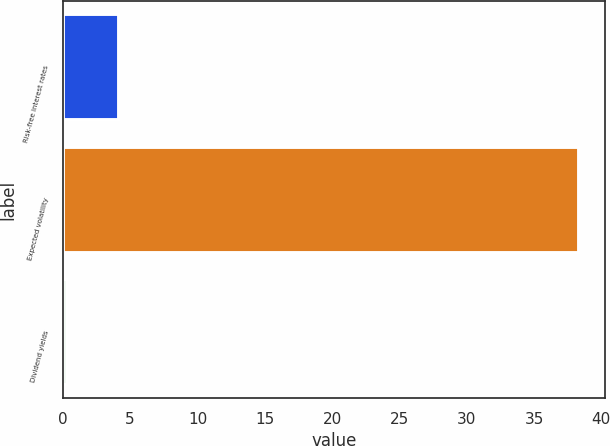Convert chart. <chart><loc_0><loc_0><loc_500><loc_500><bar_chart><fcel>Risk-free interest rates<fcel>Expected volatility<fcel>Dividend yields<nl><fcel>4.14<fcel>38.36<fcel>0.34<nl></chart> 